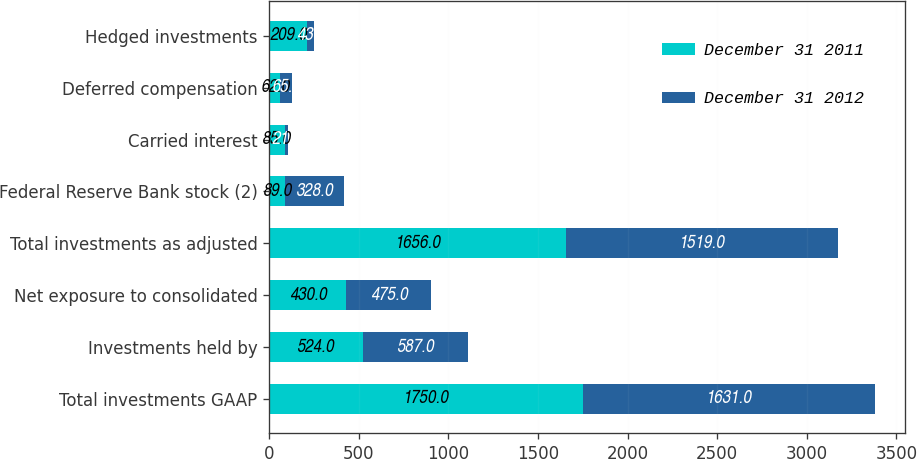Convert chart. <chart><loc_0><loc_0><loc_500><loc_500><stacked_bar_chart><ecel><fcel>Total investments GAAP<fcel>Investments held by<fcel>Net exposure to consolidated<fcel>Total investments as adjusted<fcel>Federal Reserve Bank stock (2)<fcel>Carried interest<fcel>Deferred compensation<fcel>Hedged investments<nl><fcel>December 31 2011<fcel>1750<fcel>524<fcel>430<fcel>1656<fcel>89<fcel>85<fcel>62<fcel>209<nl><fcel>December 31 2012<fcel>1631<fcel>587<fcel>475<fcel>1519<fcel>328<fcel>21<fcel>65<fcel>43<nl></chart> 